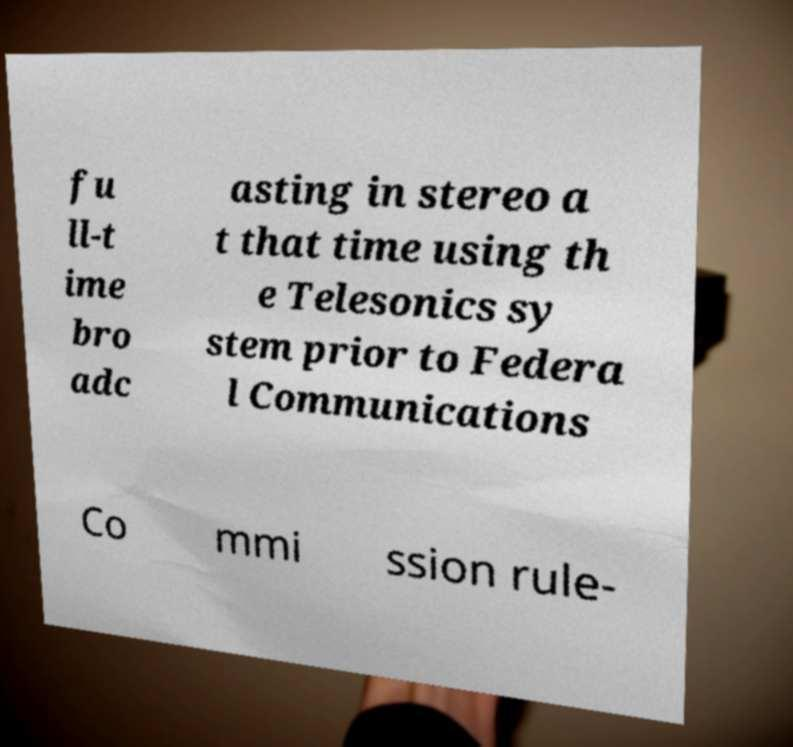There's text embedded in this image that I need extracted. Can you transcribe it verbatim? fu ll-t ime bro adc asting in stereo a t that time using th e Telesonics sy stem prior to Federa l Communications Co mmi ssion rule- 